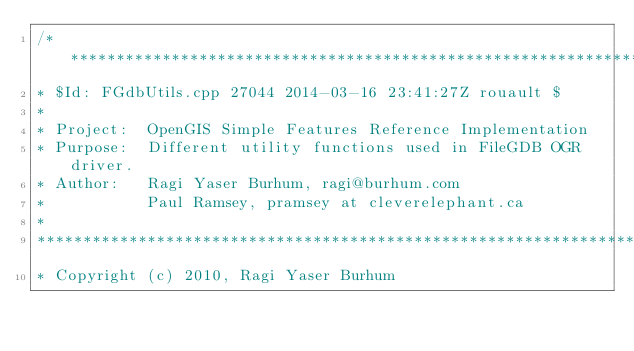<code> <loc_0><loc_0><loc_500><loc_500><_C++_>/******************************************************************************
* $Id: FGdbUtils.cpp 27044 2014-03-16 23:41:27Z rouault $
*
* Project:  OpenGIS Simple Features Reference Implementation
* Purpose:  Different utility functions used in FileGDB OGR driver.
* Author:   Ragi Yaser Burhum, ragi@burhum.com
*           Paul Ramsey, pramsey at cleverelephant.ca
*
******************************************************************************
* Copyright (c) 2010, Ragi Yaser Burhum</code> 